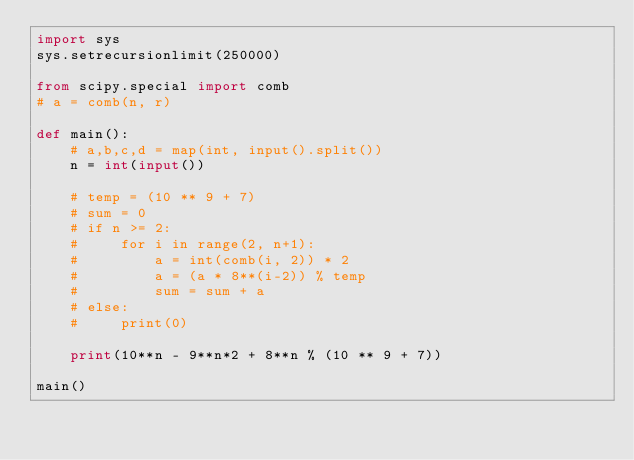<code> <loc_0><loc_0><loc_500><loc_500><_Python_>import sys
sys.setrecursionlimit(250000)

from scipy.special import comb
# a = comb(n, r)

def main():
    # a,b,c,d = map(int, input().split())
    n = int(input())

    # temp = (10 ** 9 + 7)
    # sum = 0
    # if n >= 2:
    #     for i in range(2, n+1):
    #         a = int(comb(i, 2)) * 2
    #         a = (a * 8**(i-2)) % temp
    #         sum = sum + a
    # else:
    #     print(0)

    print(10**n - 9**n*2 + 8**n % (10 ** 9 + 7))

main()
</code> 